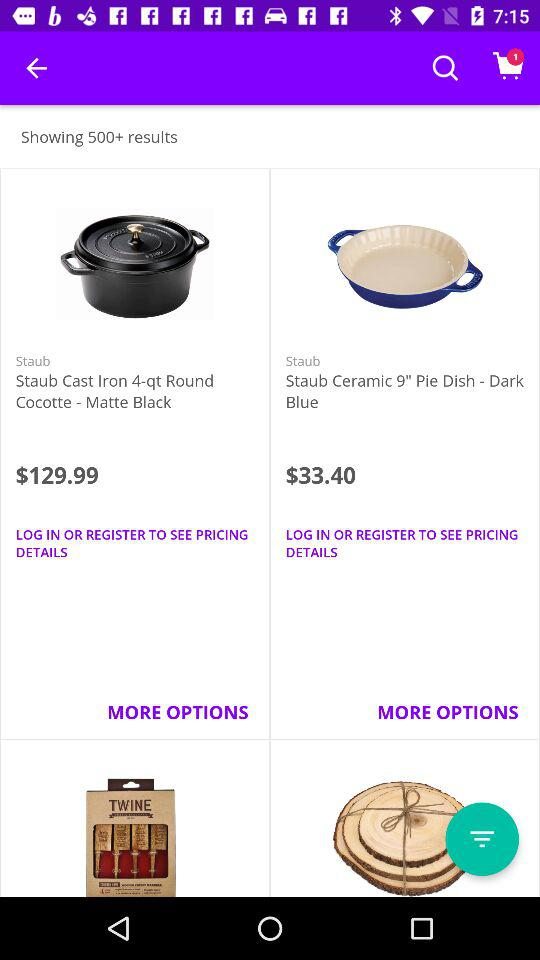What is the price of "Staub Cast Iron 4-qt"? The price of "Staub Cast Iron 4-qt" is $129.99. 